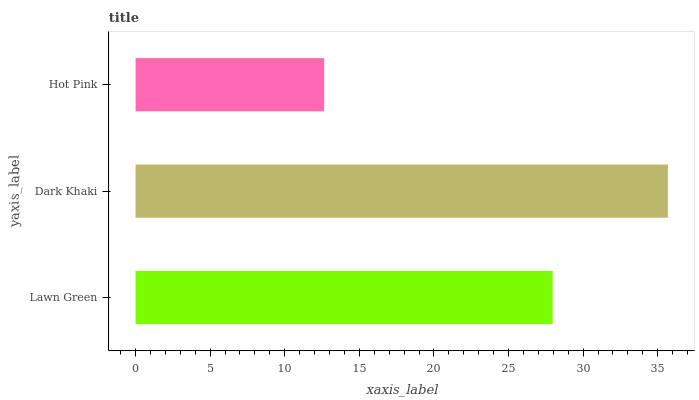Is Hot Pink the minimum?
Answer yes or no. Yes. Is Dark Khaki the maximum?
Answer yes or no. Yes. Is Dark Khaki the minimum?
Answer yes or no. No. Is Hot Pink the maximum?
Answer yes or no. No. Is Dark Khaki greater than Hot Pink?
Answer yes or no. Yes. Is Hot Pink less than Dark Khaki?
Answer yes or no. Yes. Is Hot Pink greater than Dark Khaki?
Answer yes or no. No. Is Dark Khaki less than Hot Pink?
Answer yes or no. No. Is Lawn Green the high median?
Answer yes or no. Yes. Is Lawn Green the low median?
Answer yes or no. Yes. Is Hot Pink the high median?
Answer yes or no. No. Is Hot Pink the low median?
Answer yes or no. No. 